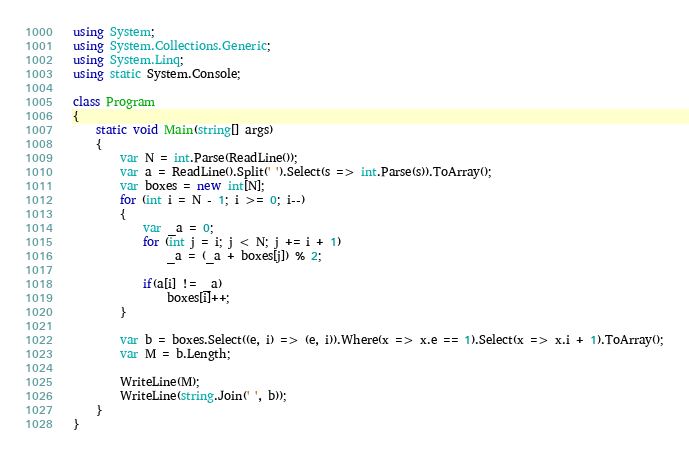Convert code to text. <code><loc_0><loc_0><loc_500><loc_500><_C#_>using System;
using System.Collections.Generic;
using System.Linq;
using static System.Console;

class Program
{
    static void Main(string[] args)
    {
        var N = int.Parse(ReadLine());
        var a = ReadLine().Split(' ').Select(s => int.Parse(s)).ToArray();
        var boxes = new int[N];
        for (int i = N - 1; i >= 0; i--)
        {
            var _a = 0;
            for (int j = i; j < N; j += i + 1)
                _a = (_a + boxes[j]) % 2;

            if(a[i] != _a)
                boxes[i]++;
        }

        var b = boxes.Select((e, i) => (e, i)).Where(x => x.e == 1).Select(x => x.i + 1).ToArray();
        var M = b.Length;

        WriteLine(M);
        WriteLine(string.Join(' ', b));
    }
}
</code> 